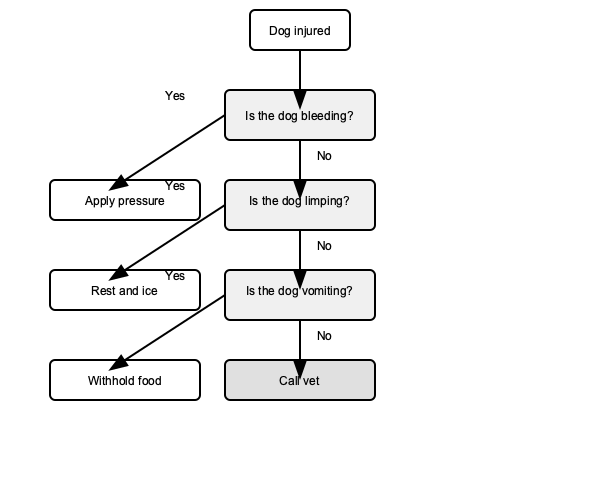In the given flowchart for basic dog first aid, what is the recommended action if the dog is not bleeding, not limping, but is vomiting? To determine the correct action based on the flowchart, we need to follow the decision tree step-by-step:

1. Start at the top with "Dog injured"
2. First decision: "Is the dog bleeding?"
   - The question states the dog is not bleeding, so we follow the "No" path
3. Second decision: "Is the dog limping?"
   - The question states the dog is not limping, so we follow the "No" path again
4. Third decision: "Is the dog vomiting?"
   - The question states the dog is vomiting, so we follow the "Yes" path
5. This leads us to the action: "Withhold food"

Therefore, according to the flowchart, if the dog is not bleeding, not limping, but is vomiting, the recommended action is to withhold food.

It's important to note that the flowchart ends with "Call vet" for any situation where none of the specific conditions are met or after taking initial actions. This emphasizes the importance of seeking professional veterinary care in any concerning situation.
Answer: Withhold food 